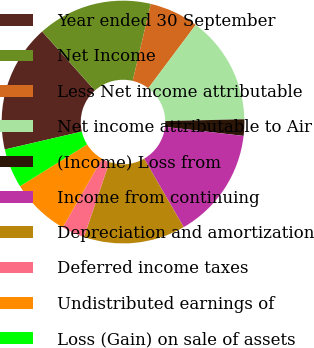Convert chart. <chart><loc_0><loc_0><loc_500><loc_500><pie_chart><fcel>Year ended 30 September<fcel>Net Income<fcel>Less Net income attributable<fcel>Net income attributable to Air<fcel>(Income) Loss from<fcel>Income from continuing<fcel>Depreciation and amortization<fcel>Deferred income taxes<fcel>Undistributed earnings of<fcel>Loss (Gain) on sale of assets<nl><fcel>17.03%<fcel>15.28%<fcel>6.55%<fcel>14.41%<fcel>2.19%<fcel>14.85%<fcel>13.54%<fcel>3.06%<fcel>7.86%<fcel>5.24%<nl></chart> 